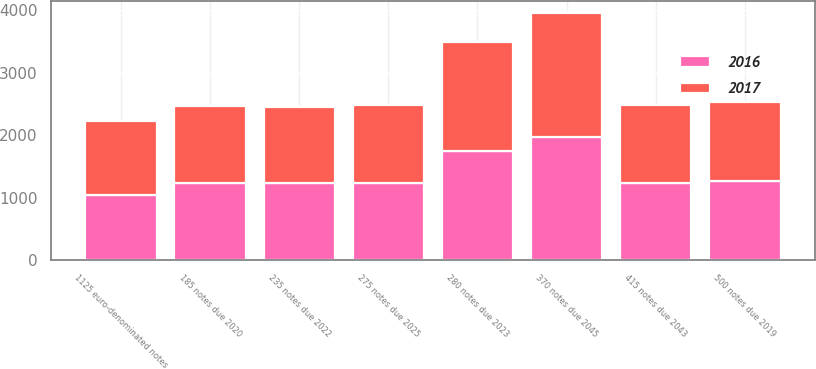Convert chart to OTSL. <chart><loc_0><loc_0><loc_500><loc_500><stacked_bar_chart><ecel><fcel>275 notes due 2025<fcel>370 notes due 2045<fcel>280 notes due 2023<fcel>500 notes due 2019<fcel>415 notes due 2043<fcel>185 notes due 2020<fcel>235 notes due 2022<fcel>1125 euro-denominated notes<nl><fcel>2017<fcel>1237.5<fcel>1973<fcel>1744<fcel>1260<fcel>1237<fcel>1232<fcel>1220<fcel>1185<nl><fcel>2016<fcel>1237.5<fcel>1972<fcel>1743<fcel>1273<fcel>1236<fcel>1238<fcel>1228<fcel>1035<nl></chart> 